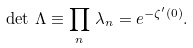<formula> <loc_0><loc_0><loc_500><loc_500>\det \, \Lambda \equiv \prod _ { n } \, \lambda _ { n } = e ^ { - \zeta ^ { \prime } ( 0 ) } .</formula> 